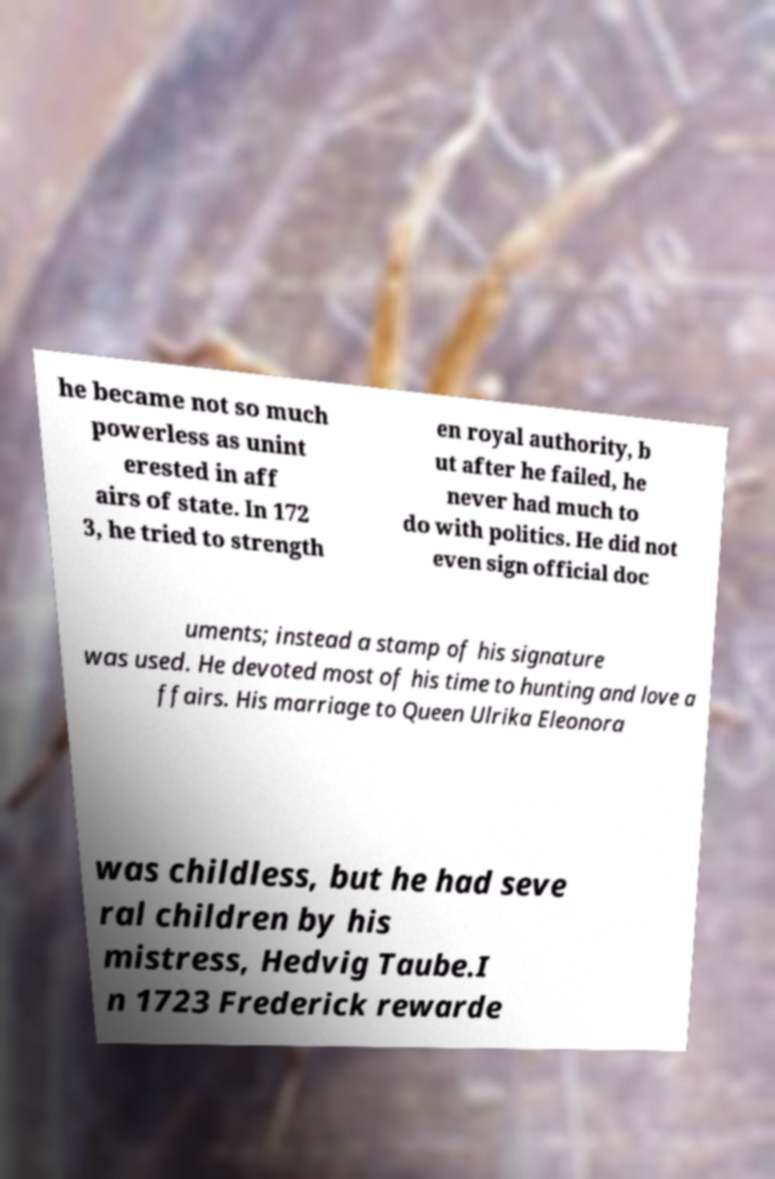Can you read and provide the text displayed in the image?This photo seems to have some interesting text. Can you extract and type it out for me? he became not so much powerless as unint erested in aff airs of state. In 172 3, he tried to strength en royal authority, b ut after he failed, he never had much to do with politics. He did not even sign official doc uments; instead a stamp of his signature was used. He devoted most of his time to hunting and love a ffairs. His marriage to Queen Ulrika Eleonora was childless, but he had seve ral children by his mistress, Hedvig Taube.I n 1723 Frederick rewarde 